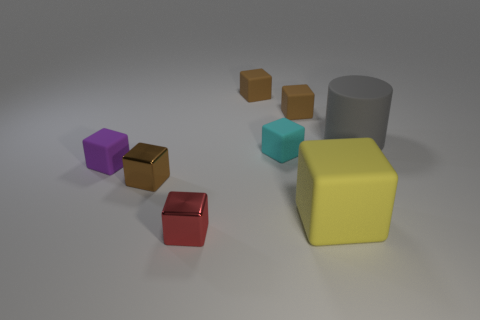There is a yellow object that is the same shape as the purple matte thing; what size is it?
Make the answer very short. Large. Is the color of the large block the same as the big cylinder?
Your answer should be very brief. No. How many large matte cubes are in front of the shiny block that is behind the red thing in front of the purple cube?
Your response must be concise. 1. Is the number of large metal cylinders greater than the number of brown cubes?
Your answer should be compact. No. How many tiny yellow rubber things are there?
Make the answer very short. 0. What is the shape of the metal thing left of the tiny metallic object right of the brown thing in front of the matte cylinder?
Give a very brief answer. Cube. Are there fewer purple cubes that are left of the purple object than yellow rubber objects behind the cyan matte thing?
Make the answer very short. No. There is a big matte thing that is behind the purple block; is it the same shape as the tiny brown rubber thing that is to the left of the cyan rubber thing?
Provide a succinct answer. No. What is the shape of the large object in front of the large gray matte cylinder to the right of the big block?
Keep it short and to the point. Cube. Are there any small brown cubes made of the same material as the large cylinder?
Your answer should be compact. Yes. 